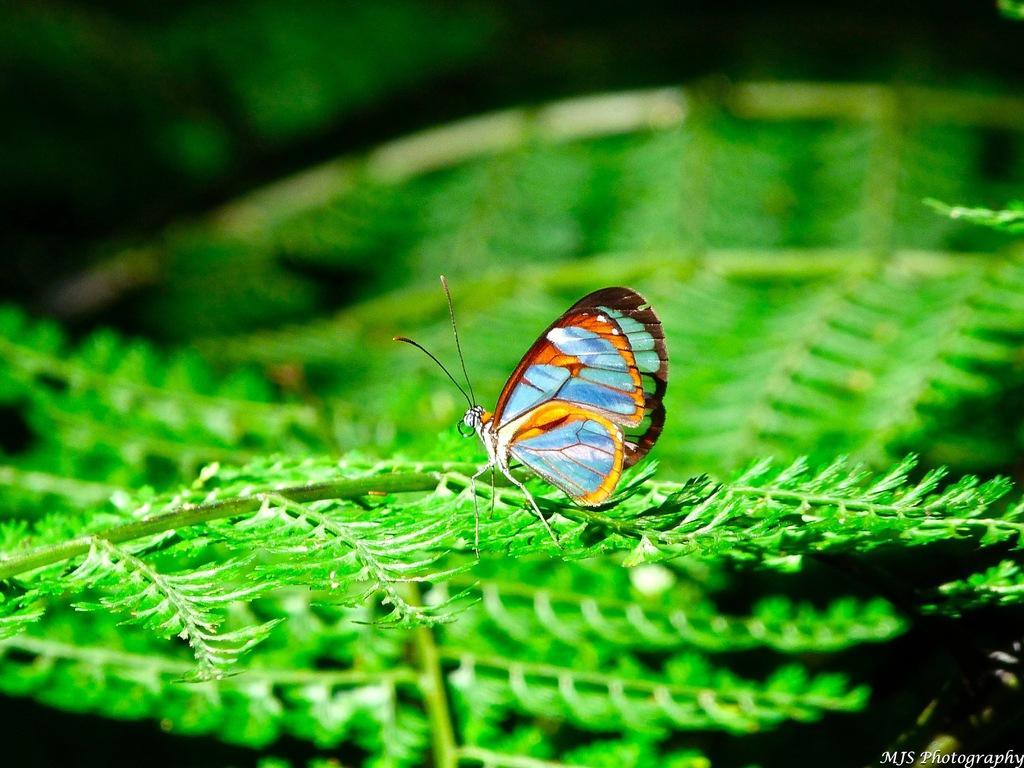Can you describe this image briefly? In the center of the image there is a butterfly on the leaf. 